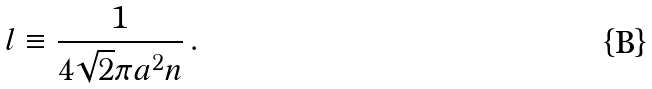<formula> <loc_0><loc_0><loc_500><loc_500>l \equiv \frac { 1 } { 4 \sqrt { 2 } \pi a ^ { 2 } n } \, .</formula> 